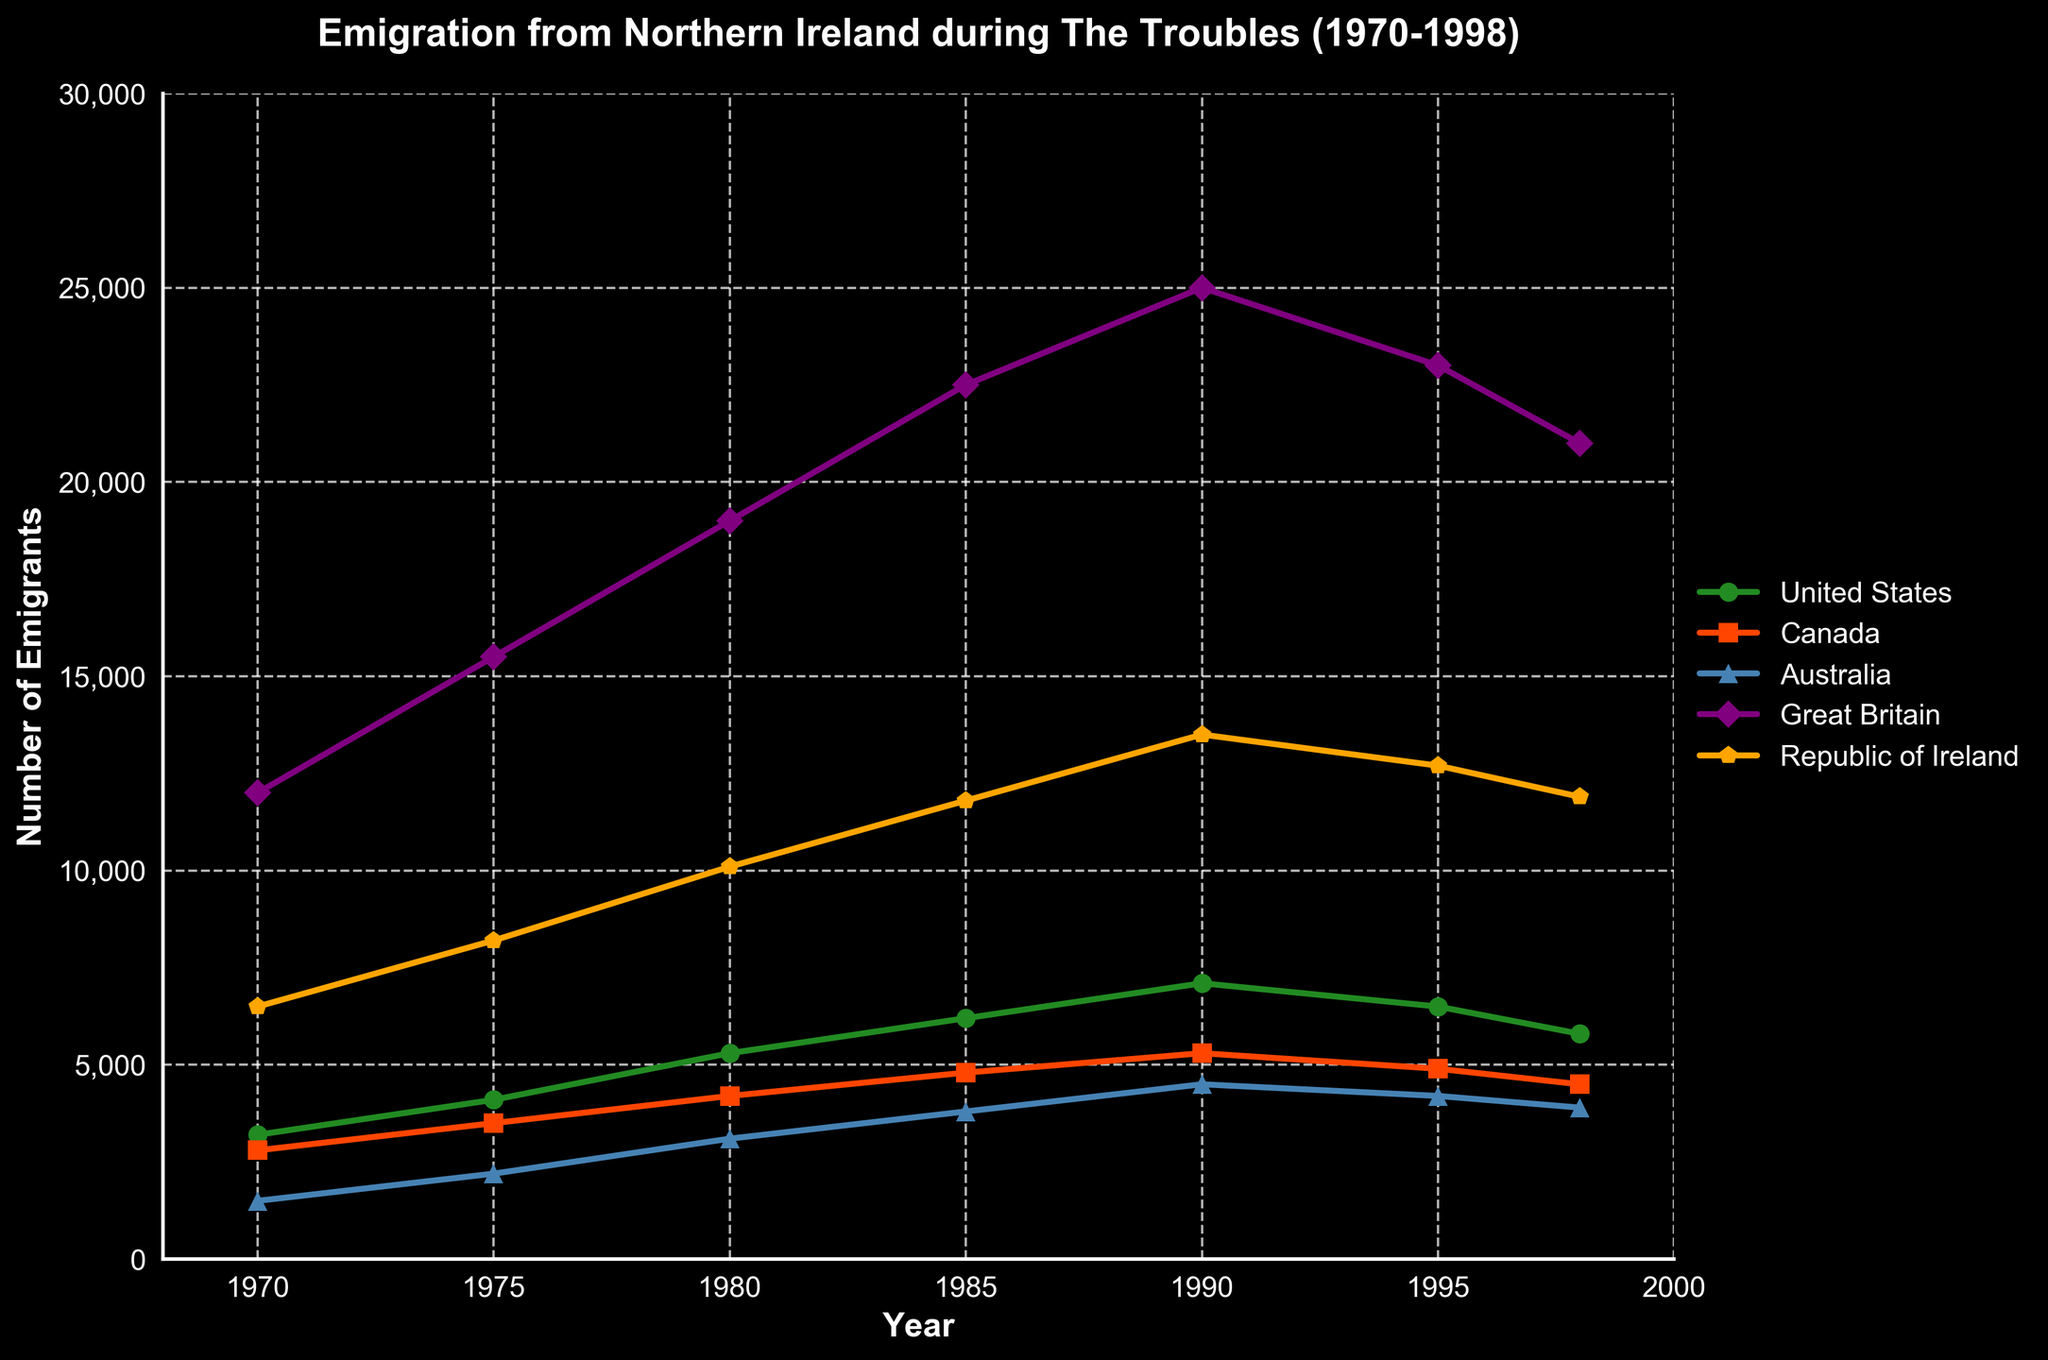What was the approximate number of emigrants to Great Britain in 1985? To find this, locate the year 1985 on the x-axis and trace upwards to the point associated with the Great Britain line. It intersects around 22,500 emigrants.
Answer: 22,500 Which country experienced the highest increase in emigration between 1970 and 1990? Examine the y-axis values for the years 1970 and 1990 for each country. Calculate the difference: 
United States (7100-3200), Canada (5300-2800), Australia (4500-1500), Great Britain (25000-12000), Republic of Ireland (13500-6500). Great Britain had the largest increase (13000).
Answer: Great Britain Compare the trends in emigration to the United States and Republic of Ireland between 1970 and 1998. Which country shows a general decline in emigration? Observe the United States and Republic of Ireland lines. The United States peaks in 1990 at 7100 and declines to 5800 by 1998. The Republic of Ireland peaks in 1990 at 13500 and declines slightly but less steeply, only a minor decrease after 1995.
Answer: United States What is the sum of emigrants to Australia and Canada in 1980? Find the values for Australia and Canada in 1980 and add them together. Australia had approximately 3100 emigrants, and Canada had 4200. Summing these gives: 3100 + 4200 = 7300.
Answer: 7300 By how much did emigration to Great Britain change from 1990 to 1998? Locate the values for Great Britain in 1990 and 1998. In 1990, it was around 25000; in 1998, it was around 21000. Subtract the later value from the earlier: 25000 - 21000 = 4000.
Answer: 4000 Which country had the most consistent rate of increase in emigration during the entire period? To determine this, look for the line that shows a relatively steady rise without major peaks or drops. The United States shows a consistent upward trend from 1970 to 1990 before declining slightly after 1990.
Answer: United States What is the difference in the number of emigrants to Canada between 1975 and 1995? Locate the emigration numbers for Canada in 1975 (approximately 3500) and 1995 (approximately 4900). Subtract the former from the latter: 4900 - 3500 = 1400.
Answer: 1400 Which country's emigration trend appears to be most volatile (most fluctuations) during the period? To find the most volatile trend, look for the line with the most ups and downs. The Republic of Ireland shows several sharp increases and decreases over the period, indicating a volatile trend.
Answer: Republic of Ireland 